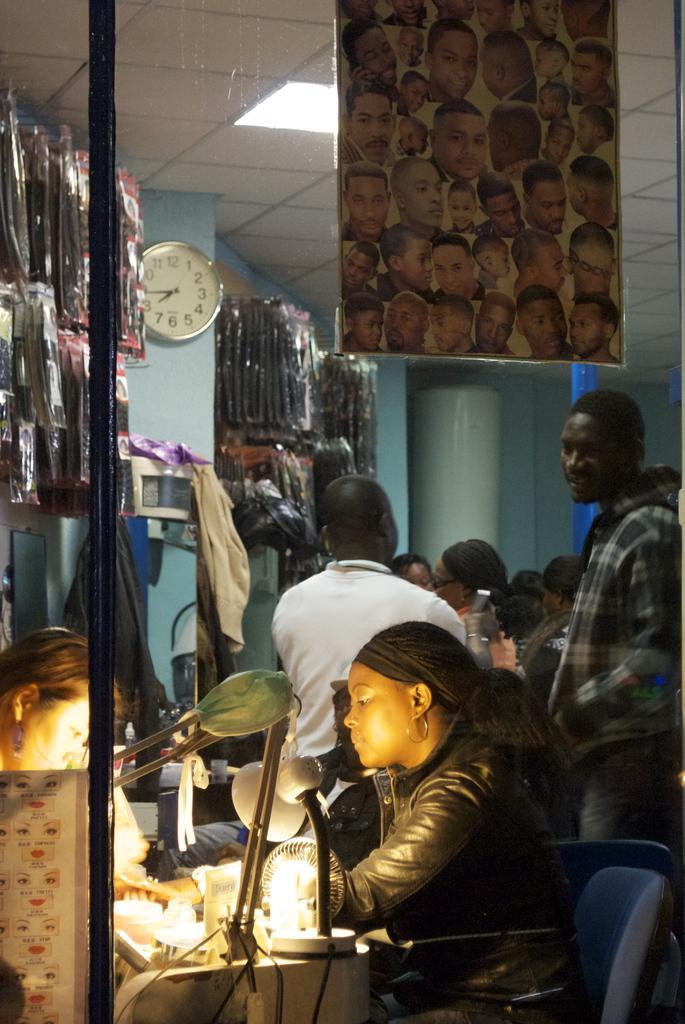In one or two sentences, can you explain what this image depicts? In this image there are some persons standing, in the foreground there are two woman sitting and there are some fans, lamp are there on the table. And also there are some other objects on the table, and there is one clock in the center. And also there are some packets, and in the foreground there is one board. In the foreground it seems that there is a glass window, at the top there is ceiling and lights. In the background there are pillars. 